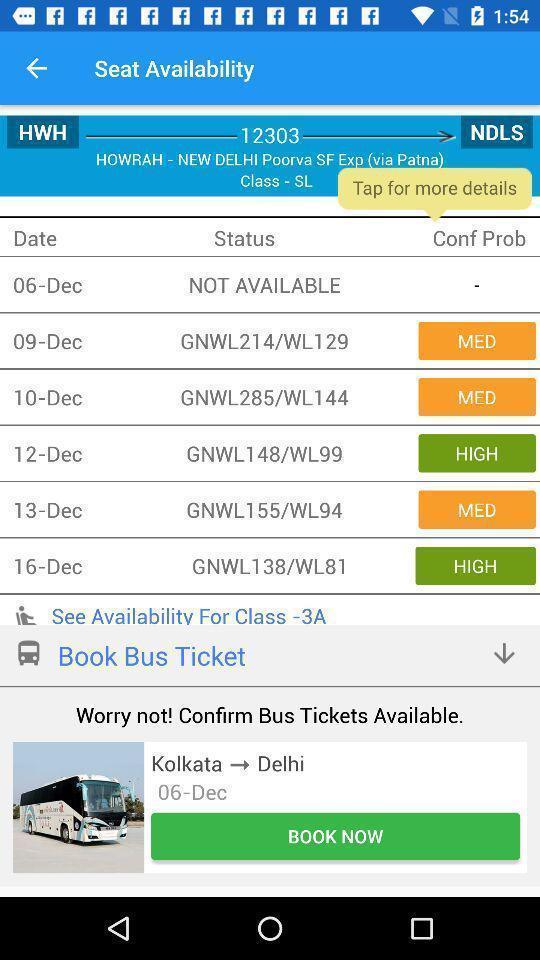What details can you identify in this image? Window displaying a train app. 